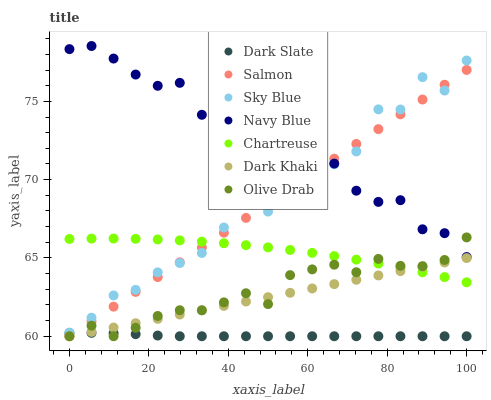Does Dark Slate have the minimum area under the curve?
Answer yes or no. Yes. Does Navy Blue have the maximum area under the curve?
Answer yes or no. Yes. Does Salmon have the minimum area under the curve?
Answer yes or no. No. Does Salmon have the maximum area under the curve?
Answer yes or no. No. Is Salmon the smoothest?
Answer yes or no. Yes. Is Sky Blue the roughest?
Answer yes or no. Yes. Is Dark Khaki the smoothest?
Answer yes or no. No. Is Dark Khaki the roughest?
Answer yes or no. No. Does Salmon have the lowest value?
Answer yes or no. Yes. Does Chartreuse have the lowest value?
Answer yes or no. No. Does Navy Blue have the highest value?
Answer yes or no. Yes. Does Salmon have the highest value?
Answer yes or no. No. Is Olive Drab less than Sky Blue?
Answer yes or no. Yes. Is Navy Blue greater than Dark Slate?
Answer yes or no. Yes. Does Dark Khaki intersect Dark Slate?
Answer yes or no. Yes. Is Dark Khaki less than Dark Slate?
Answer yes or no. No. Is Dark Khaki greater than Dark Slate?
Answer yes or no. No. Does Olive Drab intersect Sky Blue?
Answer yes or no. No. 